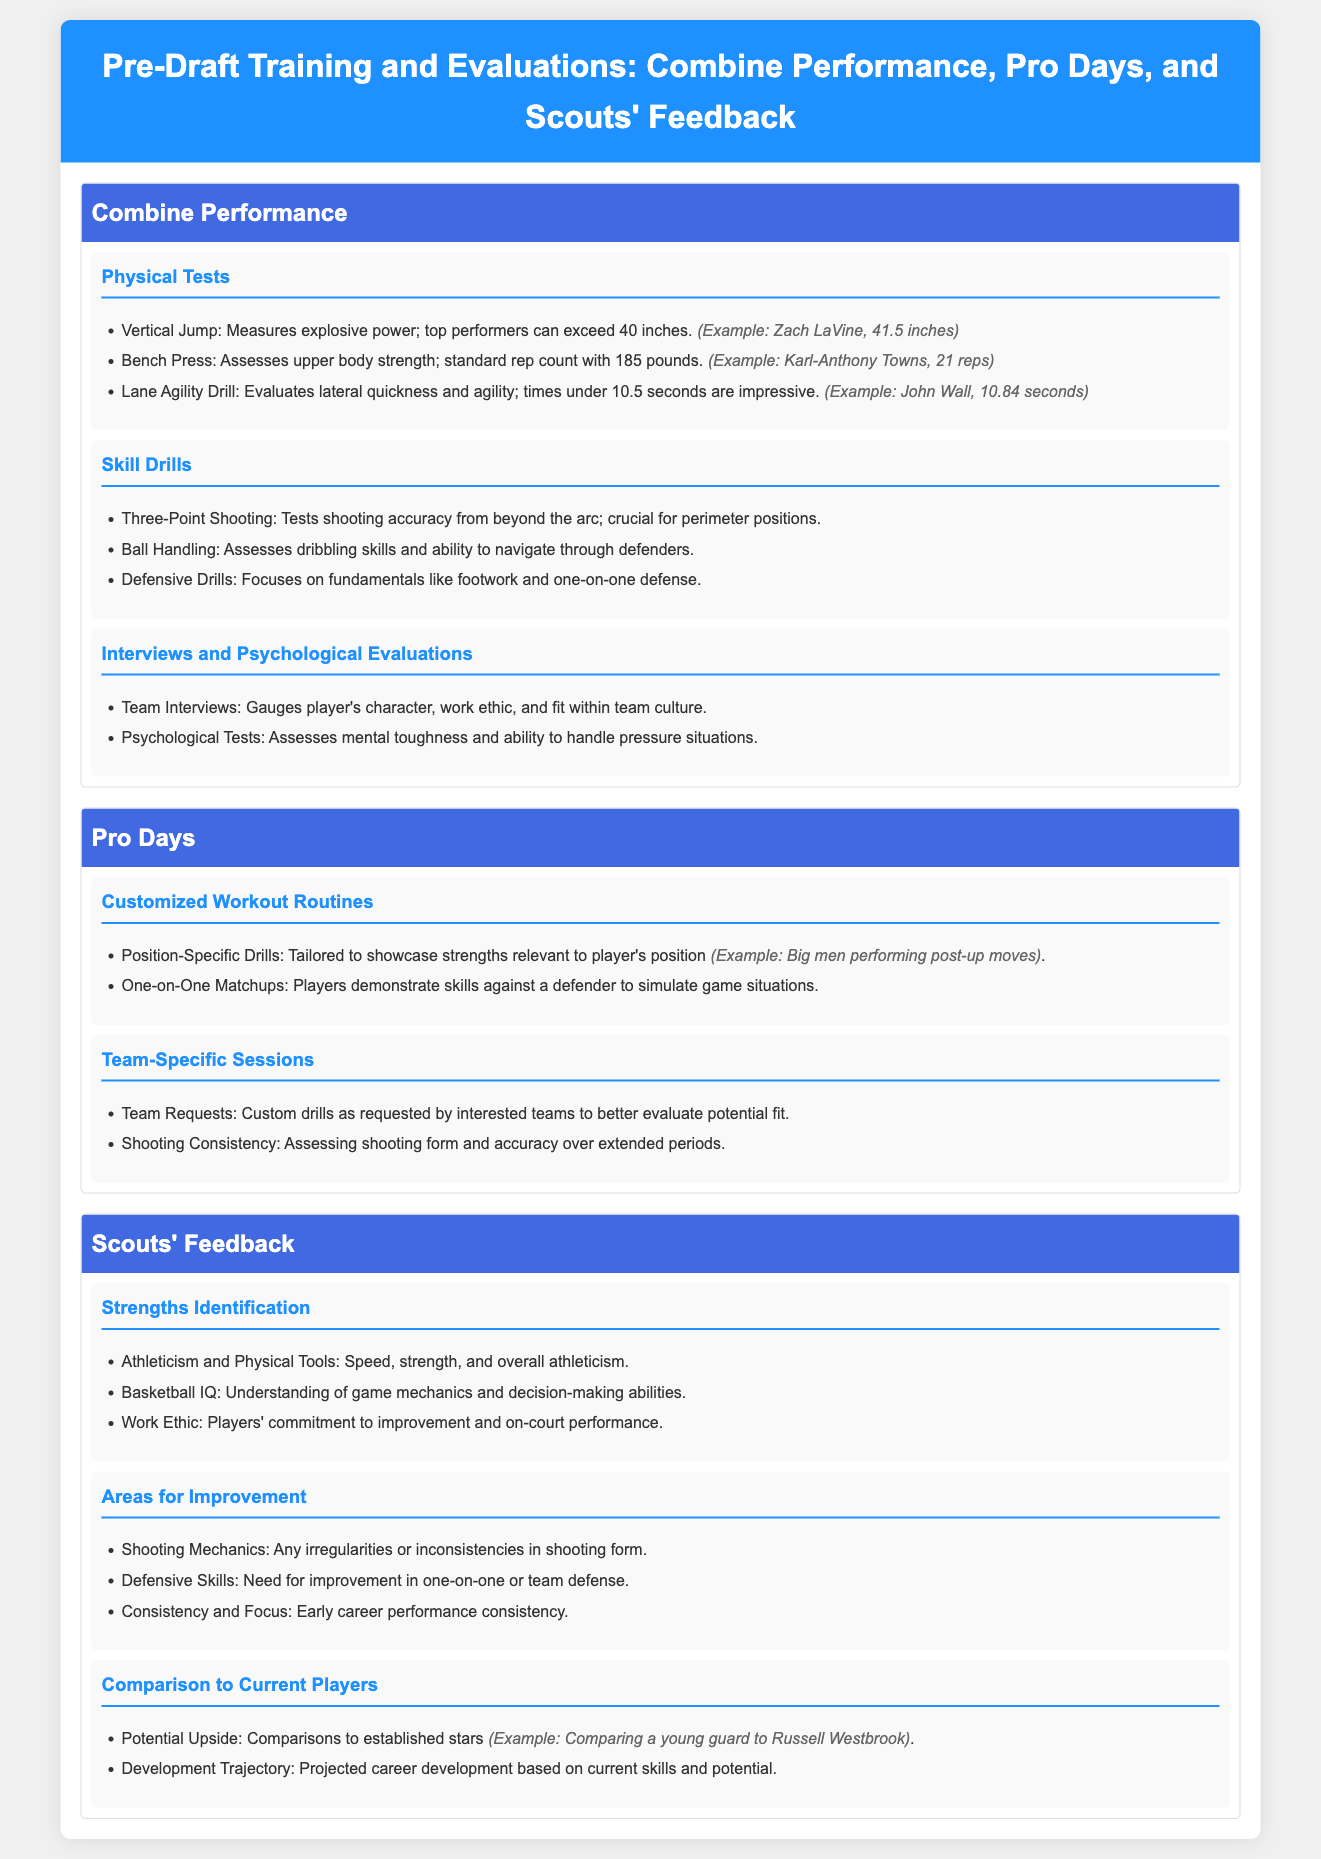What is the highest vertical jump recorded? The highest vertical jump recorded in the document is 41.5 inches by Zach LaVine.
Answer: 41.5 inches How many reps did Karl-Anthony Towns complete in the bench press? The document states that Karl-Anthony Towns completed 21 reps in the bench press.
Answer: 21 reps What is considered an impressive time for the Lane Agility Drill? An impressive time for the Lane Agility Drill is under 10.5 seconds.
Answer: Under 10.5 seconds What type of drills are tailored specifically to a player's position during Pro Days? The drills tailored specifically to a player's position are called position-specific drills.
Answer: Position-specific drills What aspect of a player's skills is assessed through psychological tests? Psychological tests assess a player's mental toughness.
Answer: Mental toughness Which two types of skills are focused on in defensive drills? Defensive drills focus on fundamentals such as footwork and one-on-one defense.
Answer: Footwork and one-on-one defense What is a key area of improvement identified by scouts regarding shooting? One key area of improvement identified is shooting mechanics.
Answer: Shooting mechanics Who might a young guard be compared to in terms of potential upside? A young guard might be compared to established stars like Russell Westbrook.
Answer: Russell Westbrook What are team-specific sessions designed to assess? Team-specific sessions are designed to assess shooting form and accuracy over extended periods.
Answer: Shooting form and accuracy 